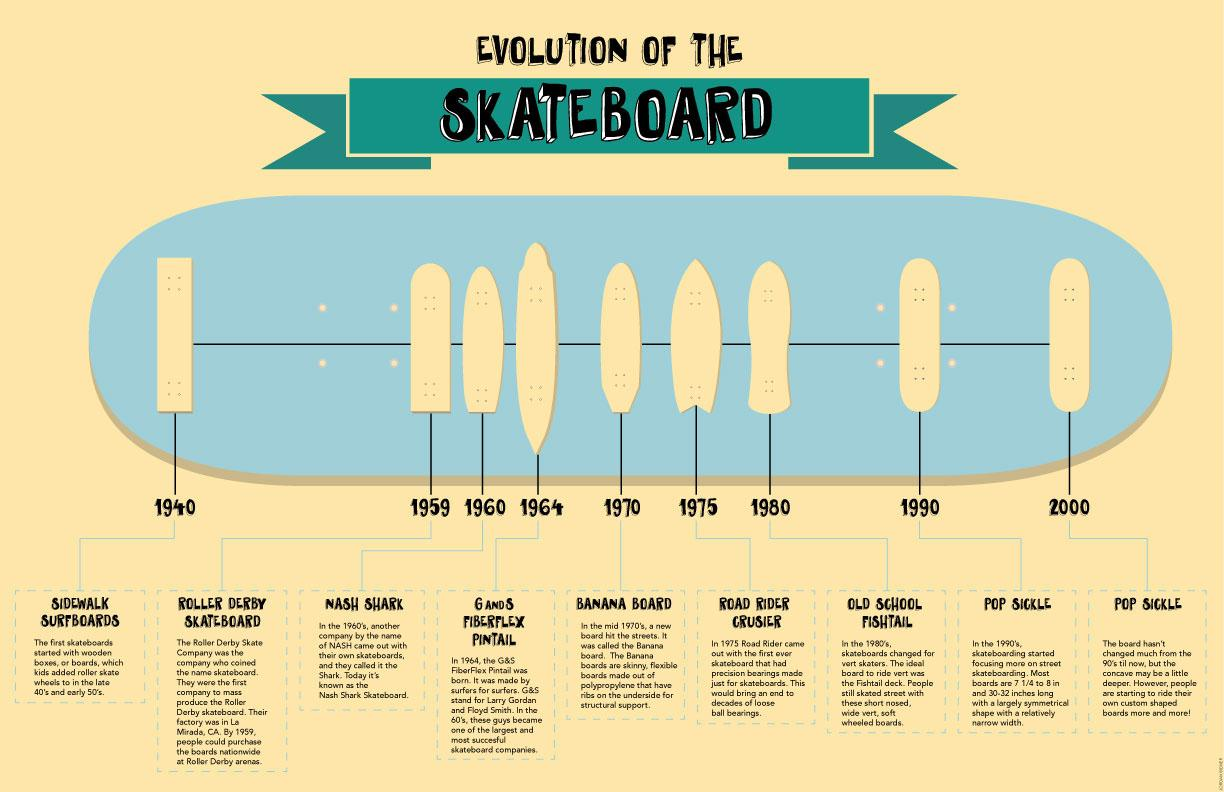Outline some significant characteristics in this image. The Nash Shark was introduced in 1960. The old school fishtail was introduced in 1980. In 1964, the G and S Fiberflex Pintail board was introduced. After 1990, it took approximately 10 years for the new design to be implemented. The name of the skateboard with precision bearings was the Road Rider Cruiser. 